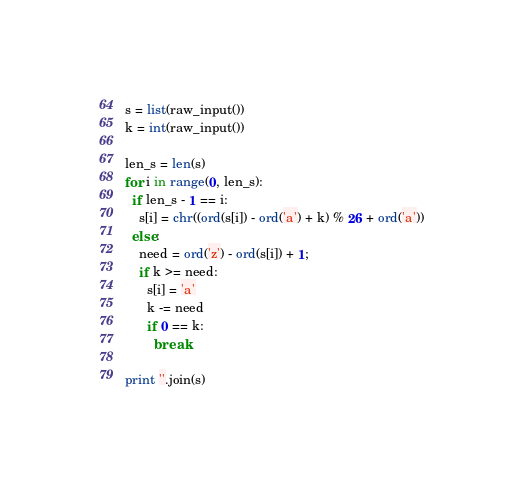<code> <loc_0><loc_0><loc_500><loc_500><_Python_>s = list(raw_input())
k = int(raw_input())

len_s = len(s)
for i in range(0, len_s):
  if len_s - 1 == i:
    s[i] = chr((ord(s[i]) - ord('a') + k) % 26 + ord('a'))
  else:
    need = ord('z') - ord(s[i]) + 1;
    if k >= need:
      s[i] = 'a'
      k -= need
      if 0 == k:
        break

print ''.join(s)</code> 